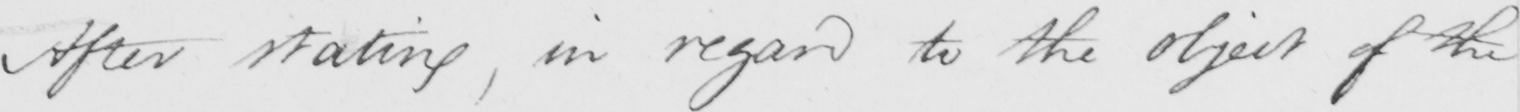Please transcribe the handwritten text in this image. After stating , in regard to the object of the 